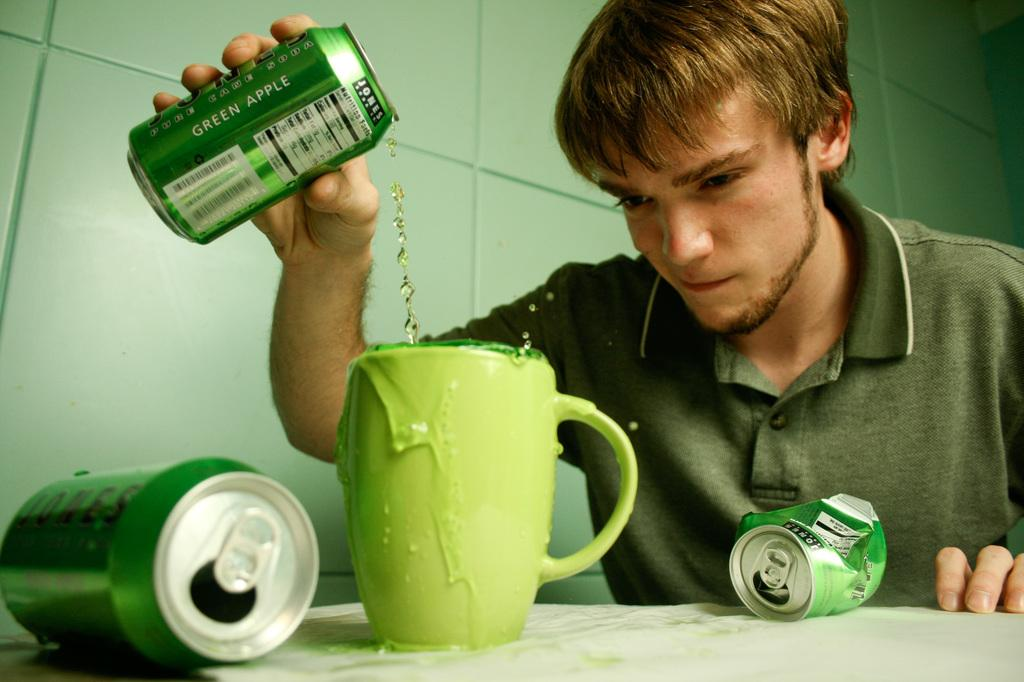What is the person in the image doing? The person is holding a soda can and pouring the drink from the soda can into a cup. What else can be seen on the table in the image? There are two other soda cans on the table. What is visible in the background of the image? There is a wall visible in the image. Can you see the person's toe in the image? A: There is no visible toe in the image; it only shows the person's upper body and the table. Is there a sidewalk in the image? There is no sidewalk present in the image; it only shows the person, the table, and the wall. 